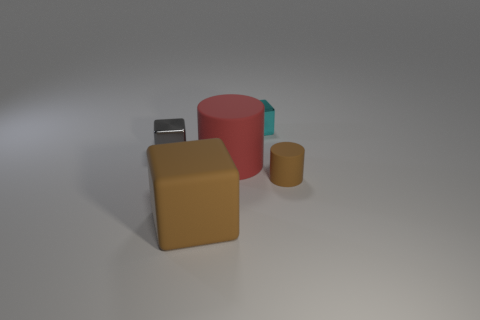Are there any shadows indicating the light source in the picture? Yes, there are shadows cast behind and to the right of each object, suggesting a light source situated to the front and left of the scene. The sharpness of the shadows indicates that the light source is somewhat direct and strong, possibly simulating a scenario with a single bright light source like the sun or a spotlight. 